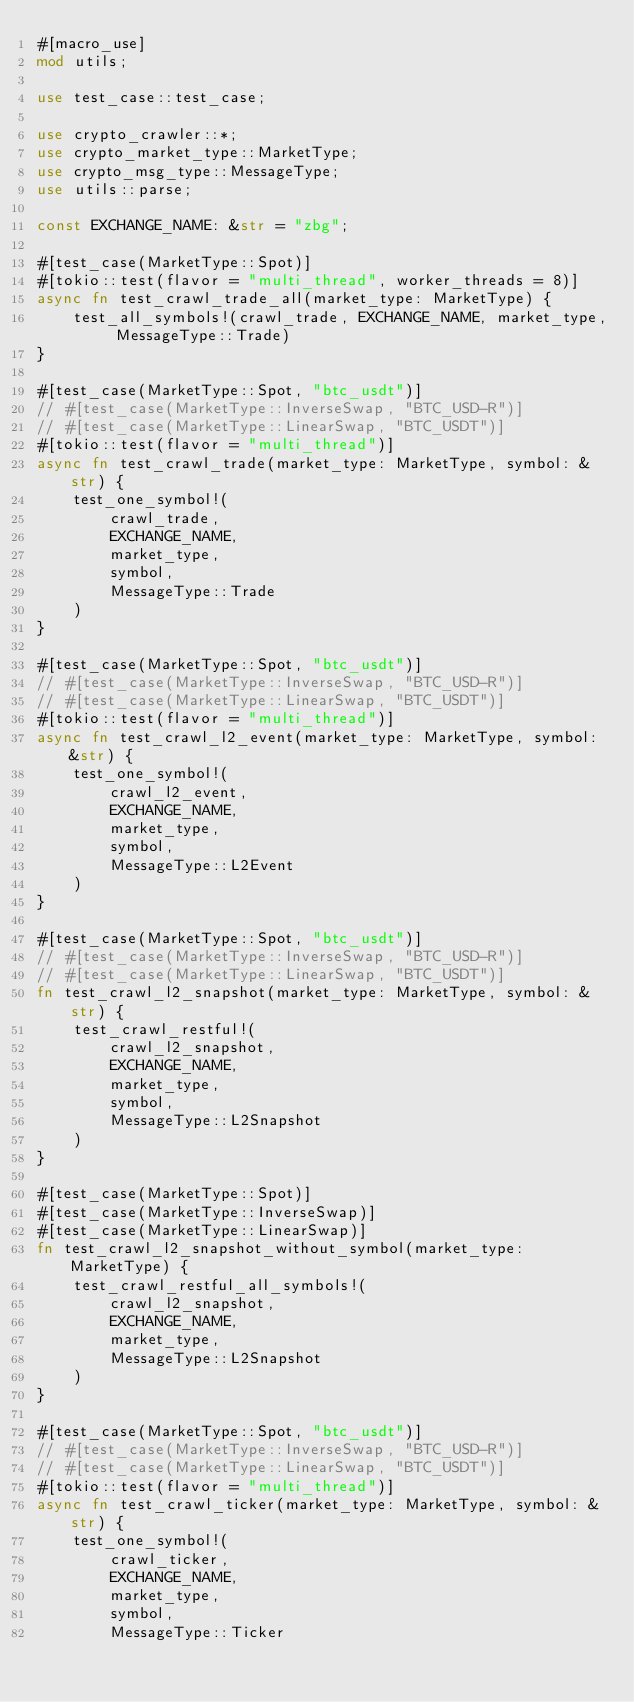<code> <loc_0><loc_0><loc_500><loc_500><_Rust_>#[macro_use]
mod utils;

use test_case::test_case;

use crypto_crawler::*;
use crypto_market_type::MarketType;
use crypto_msg_type::MessageType;
use utils::parse;

const EXCHANGE_NAME: &str = "zbg";

#[test_case(MarketType::Spot)]
#[tokio::test(flavor = "multi_thread", worker_threads = 8)]
async fn test_crawl_trade_all(market_type: MarketType) {
    test_all_symbols!(crawl_trade, EXCHANGE_NAME, market_type, MessageType::Trade)
}

#[test_case(MarketType::Spot, "btc_usdt")]
// #[test_case(MarketType::InverseSwap, "BTC_USD-R")]
// #[test_case(MarketType::LinearSwap, "BTC_USDT")]
#[tokio::test(flavor = "multi_thread")]
async fn test_crawl_trade(market_type: MarketType, symbol: &str) {
    test_one_symbol!(
        crawl_trade,
        EXCHANGE_NAME,
        market_type,
        symbol,
        MessageType::Trade
    )
}

#[test_case(MarketType::Spot, "btc_usdt")]
// #[test_case(MarketType::InverseSwap, "BTC_USD-R")]
// #[test_case(MarketType::LinearSwap, "BTC_USDT")]
#[tokio::test(flavor = "multi_thread")]
async fn test_crawl_l2_event(market_type: MarketType, symbol: &str) {
    test_one_symbol!(
        crawl_l2_event,
        EXCHANGE_NAME,
        market_type,
        symbol,
        MessageType::L2Event
    )
}

#[test_case(MarketType::Spot, "btc_usdt")]
// #[test_case(MarketType::InverseSwap, "BTC_USD-R")]
// #[test_case(MarketType::LinearSwap, "BTC_USDT")]
fn test_crawl_l2_snapshot(market_type: MarketType, symbol: &str) {
    test_crawl_restful!(
        crawl_l2_snapshot,
        EXCHANGE_NAME,
        market_type,
        symbol,
        MessageType::L2Snapshot
    )
}

#[test_case(MarketType::Spot)]
#[test_case(MarketType::InverseSwap)]
#[test_case(MarketType::LinearSwap)]
fn test_crawl_l2_snapshot_without_symbol(market_type: MarketType) {
    test_crawl_restful_all_symbols!(
        crawl_l2_snapshot,
        EXCHANGE_NAME,
        market_type,
        MessageType::L2Snapshot
    )
}

#[test_case(MarketType::Spot, "btc_usdt")]
// #[test_case(MarketType::InverseSwap, "BTC_USD-R")]
// #[test_case(MarketType::LinearSwap, "BTC_USDT")]
#[tokio::test(flavor = "multi_thread")]
async fn test_crawl_ticker(market_type: MarketType, symbol: &str) {
    test_one_symbol!(
        crawl_ticker,
        EXCHANGE_NAME,
        market_type,
        symbol,
        MessageType::Ticker</code> 